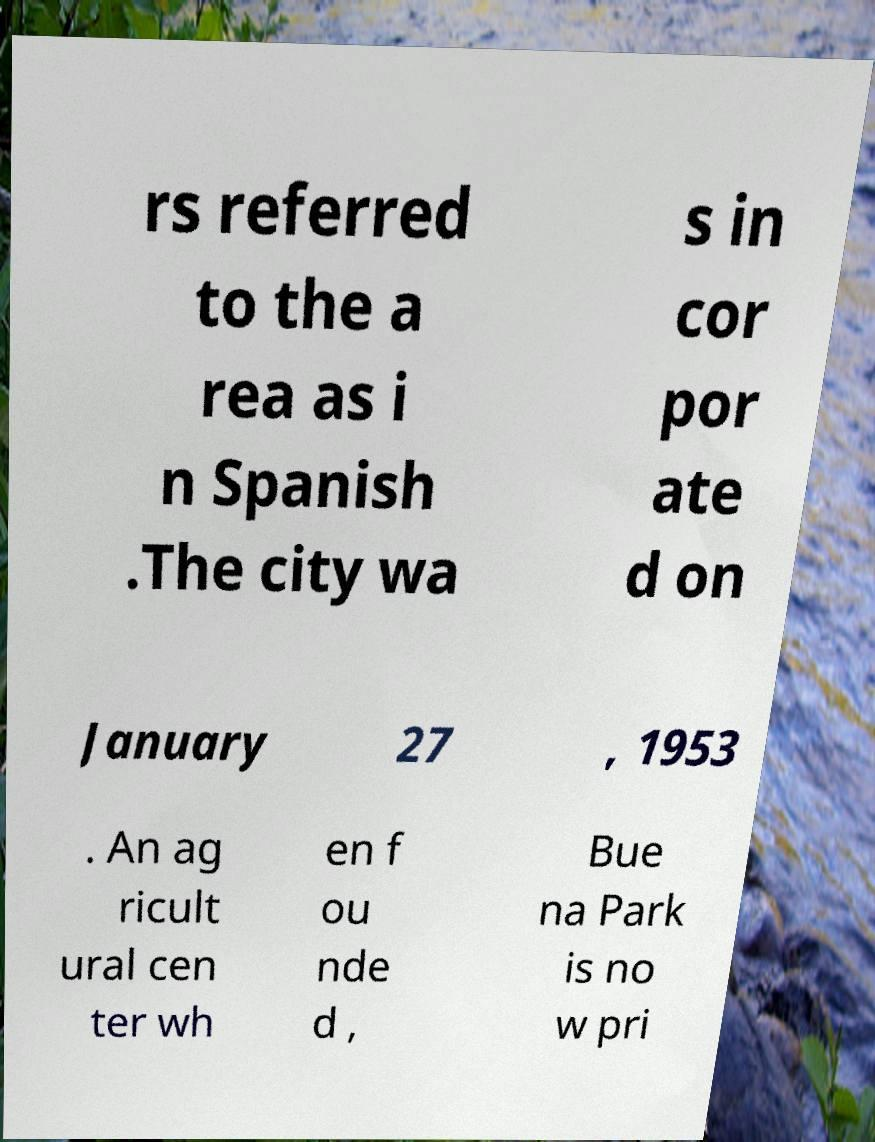There's text embedded in this image that I need extracted. Can you transcribe it verbatim? rs referred to the a rea as i n Spanish .The city wa s in cor por ate d on January 27 , 1953 . An ag ricult ural cen ter wh en f ou nde d , Bue na Park is no w pri 